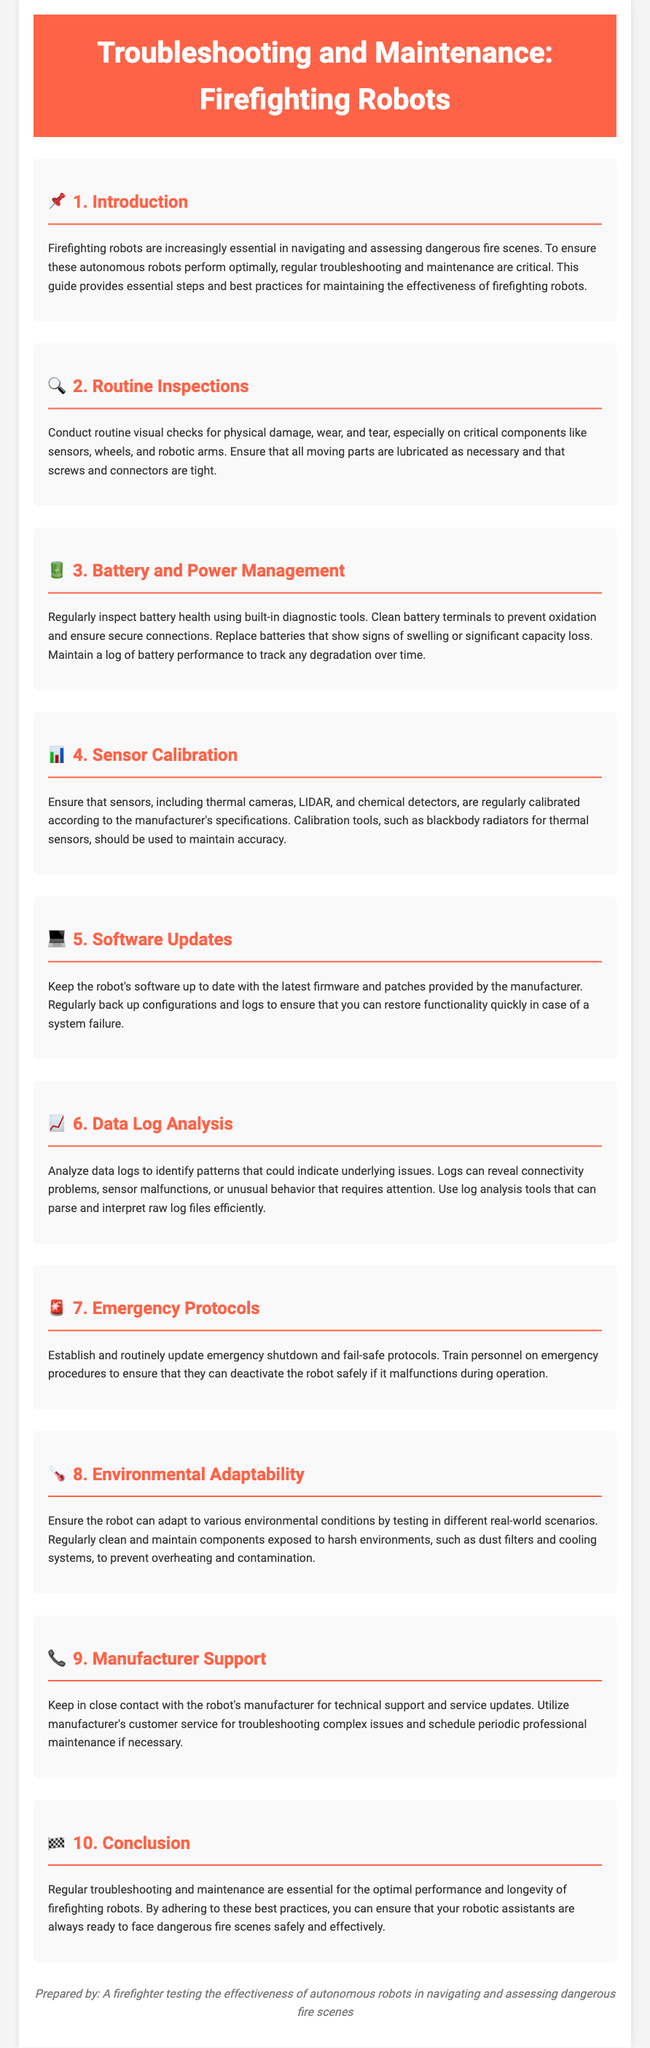What is the main focus of this guide? The main focus of the guide is on troubleshooting and maintenance for firefighting robots to ensure optimal performance.
Answer: troubleshooting and maintenance What should be inspected regularly on the robots? Regular inspections should focus on physical damage, wear, and tear on critical components such as sensors and wheels.
Answer: critical components How often should software updates be performed? The document does not specify a frequency but emphasizes that keeping software up to date is important.
Answer: regularly What type of sensors need calibration? Sensors that require calibration include thermal cameras, LIDAR, and chemical detectors.
Answer: Thermal cameras, LIDAR, chemical detectors What should be analyzed to identify patterns indicating underlying issues? Data logs should be analyzed to identify patterns that could indicate underlying issues with the robots.
Answer: data logs Which section discusses battery maintenance practices? Section 3 specifically addresses battery and power management practices for the robots.
Answer: Section 3 What is the purpose of emergency protocols mentioned in the guide? The purpose of emergency protocols is to establish shutdown and fail-safe procedures for safely deactivating the robot if it malfunctions.
Answer: deactivating the robot What does the guide recommend for environmental adaptability? The guide recommends ensuring that the robot can adapt to various environmental conditions by testing in different scenarios and cleaning components regularly.
Answer: testing and cleaning components Who should be contacted for technical support regarding the robots? The manufacturer should be contacted for technical support and service updates regarding the robots.
Answer: manufacturer 